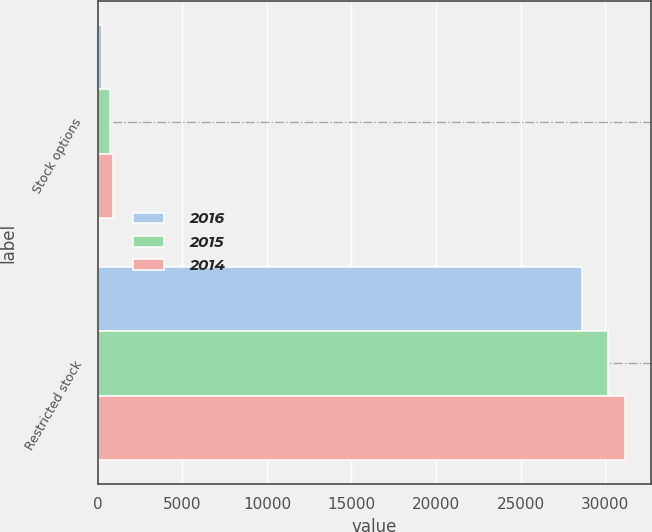Convert chart to OTSL. <chart><loc_0><loc_0><loc_500><loc_500><stacked_bar_chart><ecel><fcel>Stock options<fcel>Restricted stock<nl><fcel>2016<fcel>266<fcel>28603<nl><fcel>2015<fcel>698<fcel>30146<nl><fcel>2014<fcel>912<fcel>31163<nl></chart> 